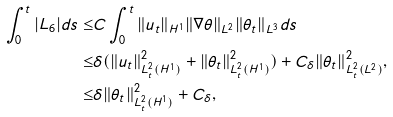<formula> <loc_0><loc_0><loc_500><loc_500>\int _ { 0 } ^ { t } | L _ { 6 } | d s \leq & C \int _ { 0 } ^ { t } \| u _ { t } \| _ { H ^ { 1 } } \| \nabla \theta \| _ { L ^ { 2 } } \| \theta _ { t } \| _ { L ^ { 3 } } d s \\ \leq & \delta ( \| u _ { t } \| _ { L ^ { 2 } _ { t } ( H ^ { 1 } ) } ^ { 2 } + \| \theta _ { t } \| _ { L ^ { 2 } _ { t } ( H ^ { 1 } ) } ^ { 2 } ) + C _ { \delta } \| \theta _ { t } \| _ { L ^ { 2 } _ { t } ( L ^ { 2 } ) } ^ { 2 } , \\ \leq & \delta \| \theta _ { t } \| _ { L ^ { 2 } _ { t } ( H ^ { 1 } ) } ^ { 2 } + C _ { \delta } ,</formula> 